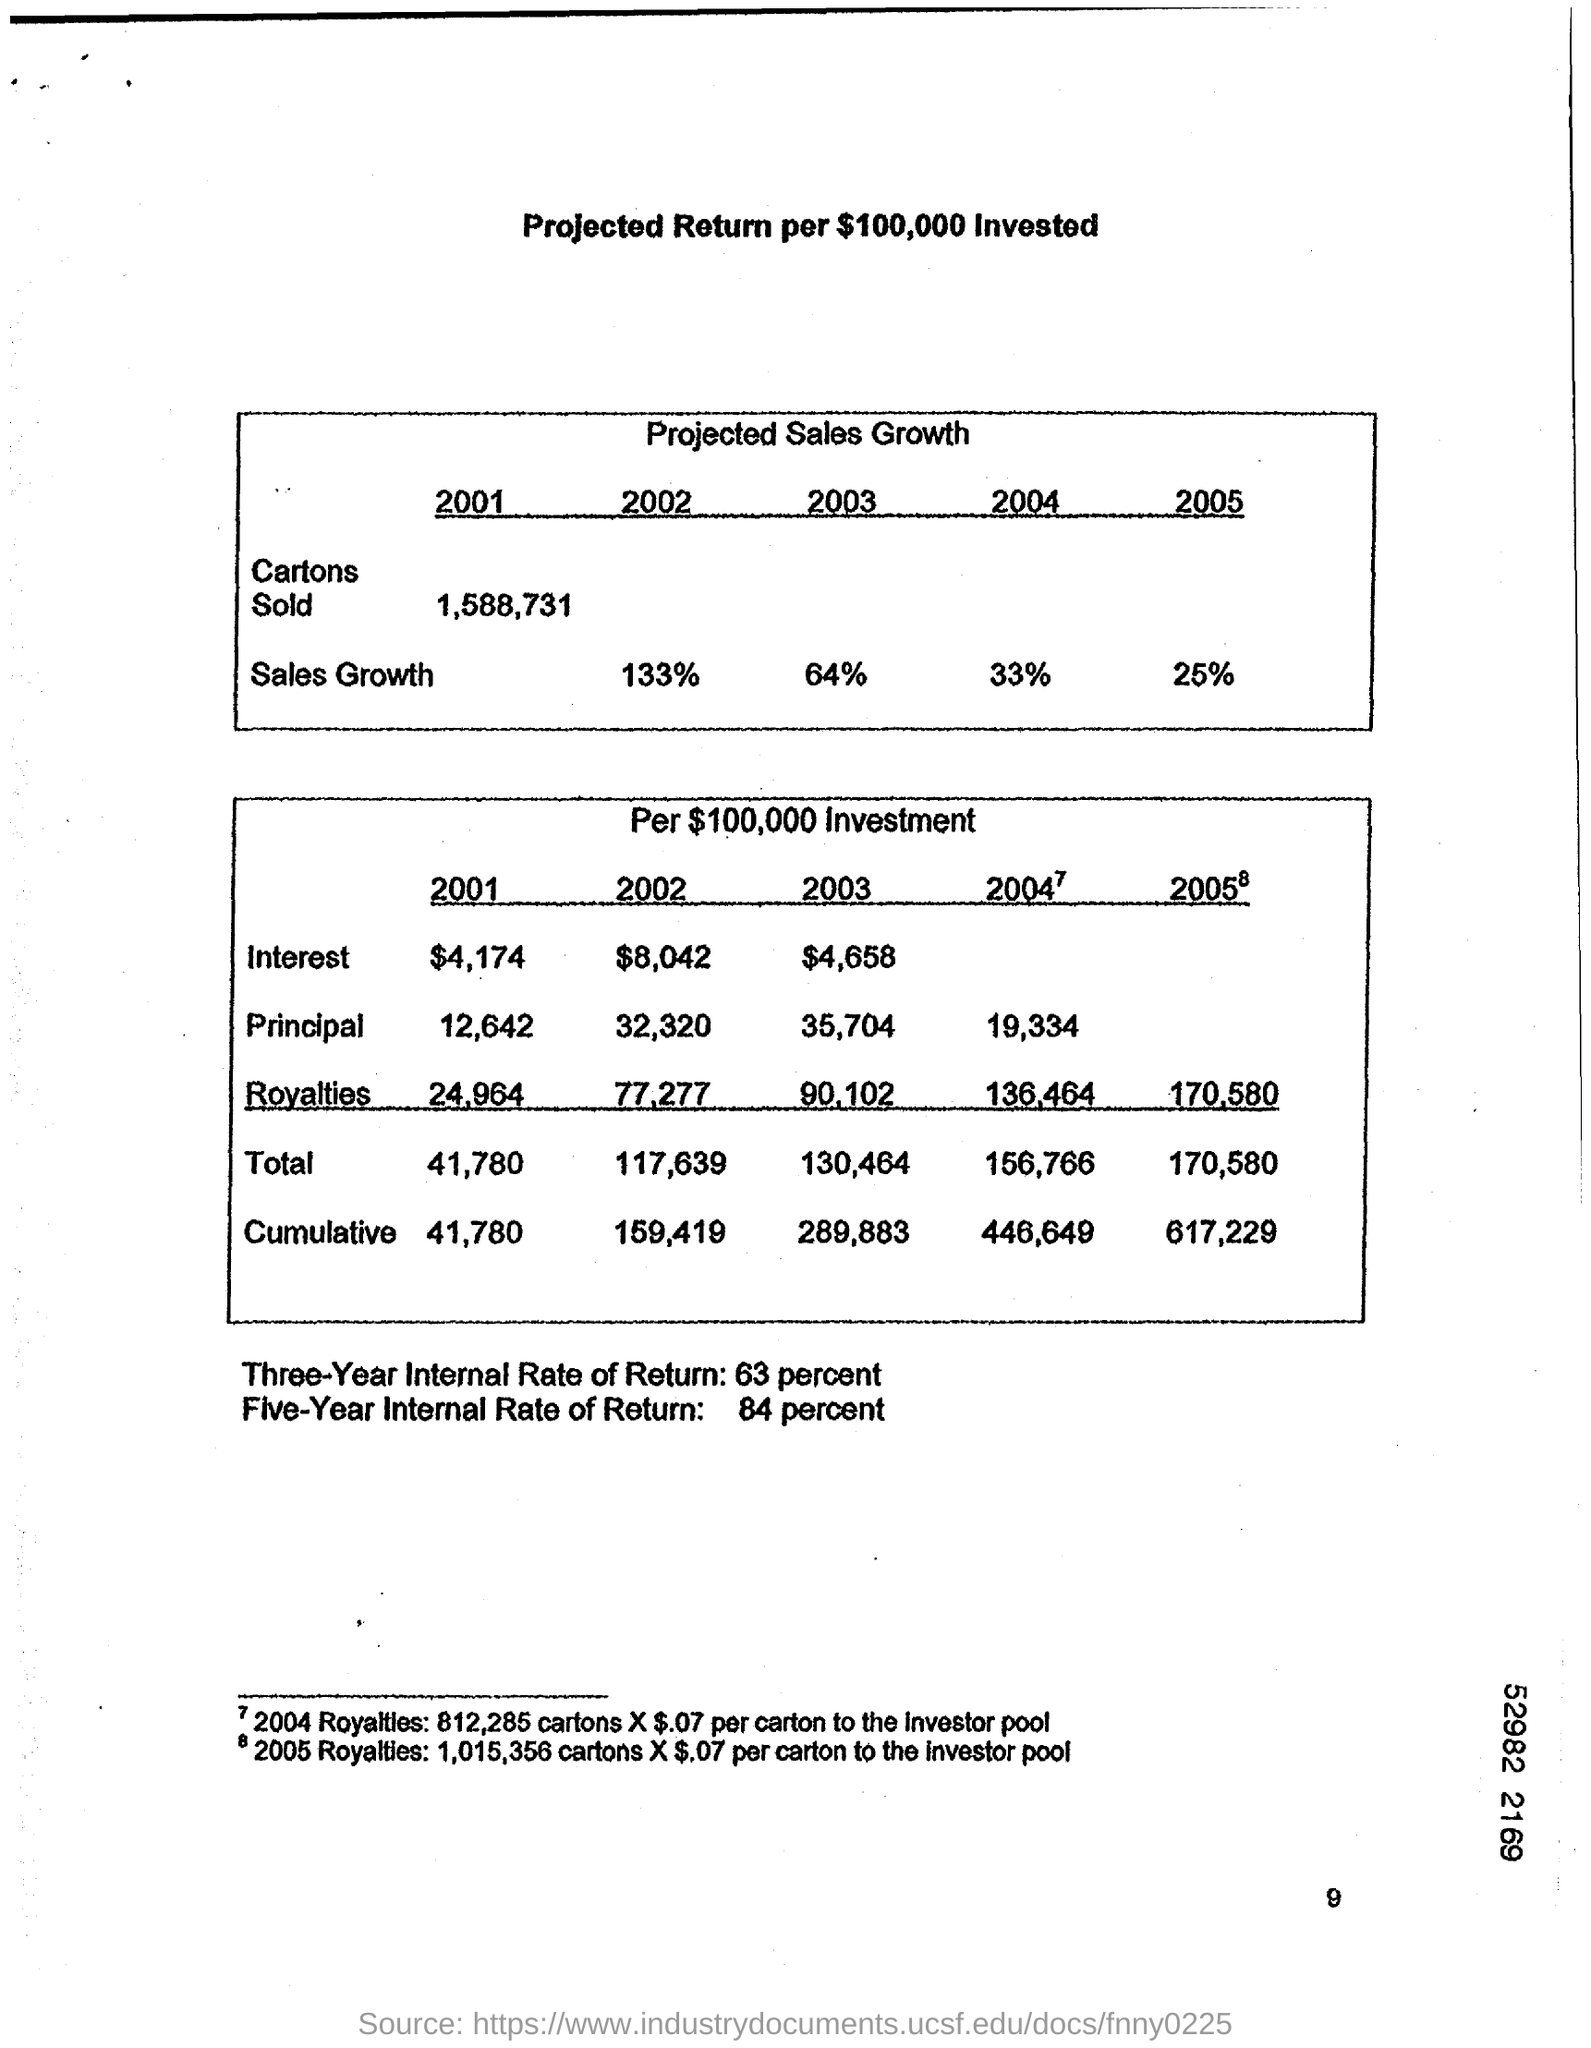What is Three-Year Internal Rate of Return?
Provide a short and direct response. 63 percent. What is Five-Year Internal Rate of Return?
Offer a very short reply. 84 percent. 